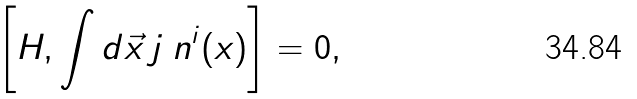Convert formula to latex. <formula><loc_0><loc_0><loc_500><loc_500>\left [ H , \int d \vec { x } \, j _ { \ } n ^ { i } ( x ) \right ] = 0 ,</formula> 